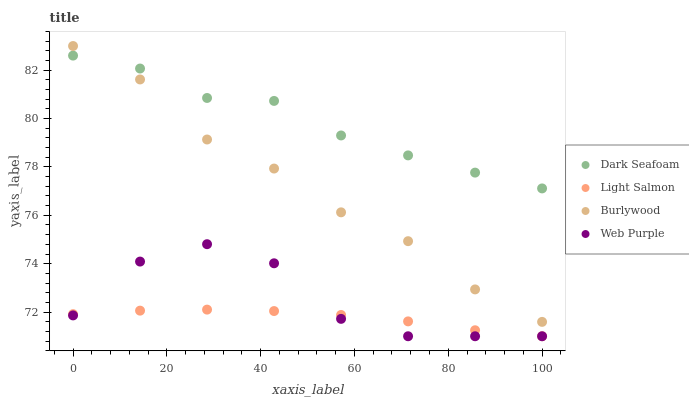Does Light Salmon have the minimum area under the curve?
Answer yes or no. Yes. Does Dark Seafoam have the maximum area under the curve?
Answer yes or no. Yes. Does Web Purple have the minimum area under the curve?
Answer yes or no. No. Does Web Purple have the maximum area under the curve?
Answer yes or no. No. Is Light Salmon the smoothest?
Answer yes or no. Yes. Is Web Purple the roughest?
Answer yes or no. Yes. Is Dark Seafoam the smoothest?
Answer yes or no. No. Is Dark Seafoam the roughest?
Answer yes or no. No. Does Web Purple have the lowest value?
Answer yes or no. Yes. Does Dark Seafoam have the lowest value?
Answer yes or no. No. Does Burlywood have the highest value?
Answer yes or no. Yes. Does Web Purple have the highest value?
Answer yes or no. No. Is Web Purple less than Burlywood?
Answer yes or no. Yes. Is Burlywood greater than Web Purple?
Answer yes or no. Yes. Does Burlywood intersect Dark Seafoam?
Answer yes or no. Yes. Is Burlywood less than Dark Seafoam?
Answer yes or no. No. Is Burlywood greater than Dark Seafoam?
Answer yes or no. No. Does Web Purple intersect Burlywood?
Answer yes or no. No. 